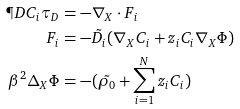Convert formula to latex. <formula><loc_0><loc_0><loc_500><loc_500>\P D { C _ { i } } { \tau _ { D } } & = - \nabla _ { X } \cdot F _ { i } \\ F _ { i } & = - \tilde { D _ { i } } ( \nabla _ { X } C _ { i } + z _ { i } C _ { i } \nabla _ { X } \Phi ) \\ \beta ^ { 2 } \Delta _ { X } \Phi & = - ( \tilde { \rho _ { 0 } } + \sum _ { i = 1 } ^ { N } z _ { i } C _ { i } )</formula> 